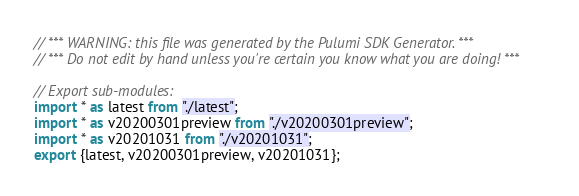<code> <loc_0><loc_0><loc_500><loc_500><_TypeScript_>// *** WARNING: this file was generated by the Pulumi SDK Generator. ***
// *** Do not edit by hand unless you're certain you know what you are doing! ***

// Export sub-modules:
import * as latest from "./latest";
import * as v20200301preview from "./v20200301preview";
import * as v20201031 from "./v20201031";
export {latest, v20200301preview, v20201031};
</code> 